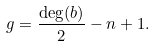<formula> <loc_0><loc_0><loc_500><loc_500>g = \frac { \deg ( b ) } { 2 } - n + 1 .</formula> 